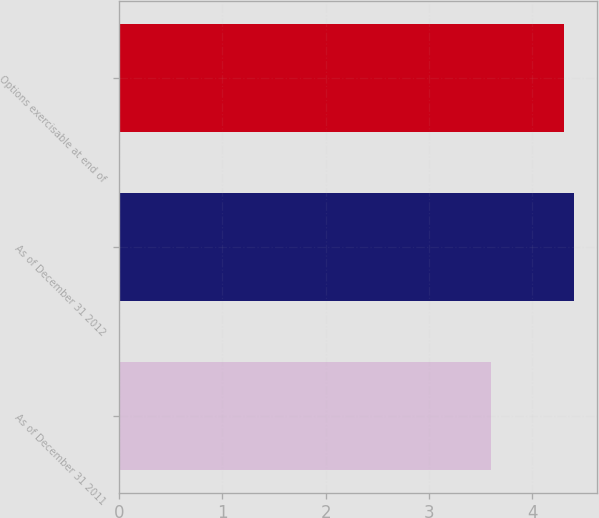Convert chart to OTSL. <chart><loc_0><loc_0><loc_500><loc_500><bar_chart><fcel>As of December 31 2011<fcel>As of December 31 2012<fcel>Options exercisable at end of<nl><fcel>3.6<fcel>4.4<fcel>4.3<nl></chart> 